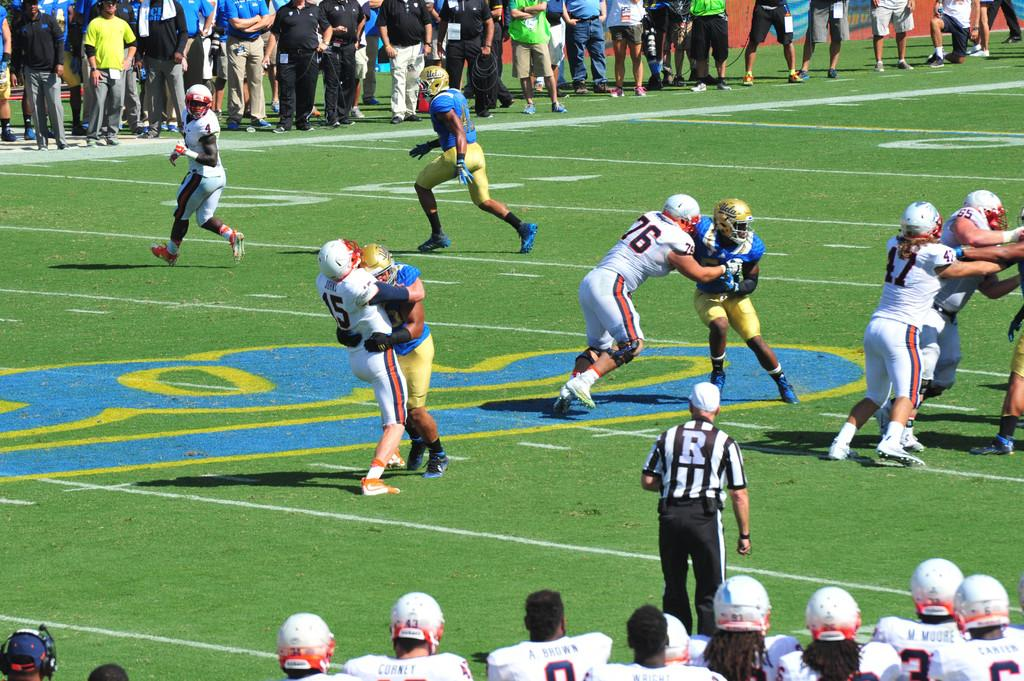What activity are the people in the image engaged in? The people in the image are playing a game. What type of surface is visible at the bottom of the image? There is grass at the bottom of the image. Can you describe the people in the background of the image? The people in the background are wearing helmets. What might be the purpose of the helmets? The helmets might be worn for safety during the game. What type of development can be seen in the image? There is no development visible in the image; it features people playing a game on a grassy surface. What kind of wine is being served in the image? There is no wine present in the image. 